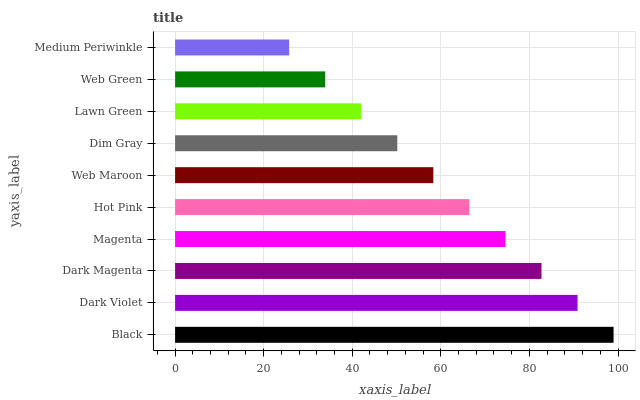Is Medium Periwinkle the minimum?
Answer yes or no. Yes. Is Black the maximum?
Answer yes or no. Yes. Is Dark Violet the minimum?
Answer yes or no. No. Is Dark Violet the maximum?
Answer yes or no. No. Is Black greater than Dark Violet?
Answer yes or no. Yes. Is Dark Violet less than Black?
Answer yes or no. Yes. Is Dark Violet greater than Black?
Answer yes or no. No. Is Black less than Dark Violet?
Answer yes or no. No. Is Hot Pink the high median?
Answer yes or no. Yes. Is Web Maroon the low median?
Answer yes or no. Yes. Is Dark Violet the high median?
Answer yes or no. No. Is Hot Pink the low median?
Answer yes or no. No. 